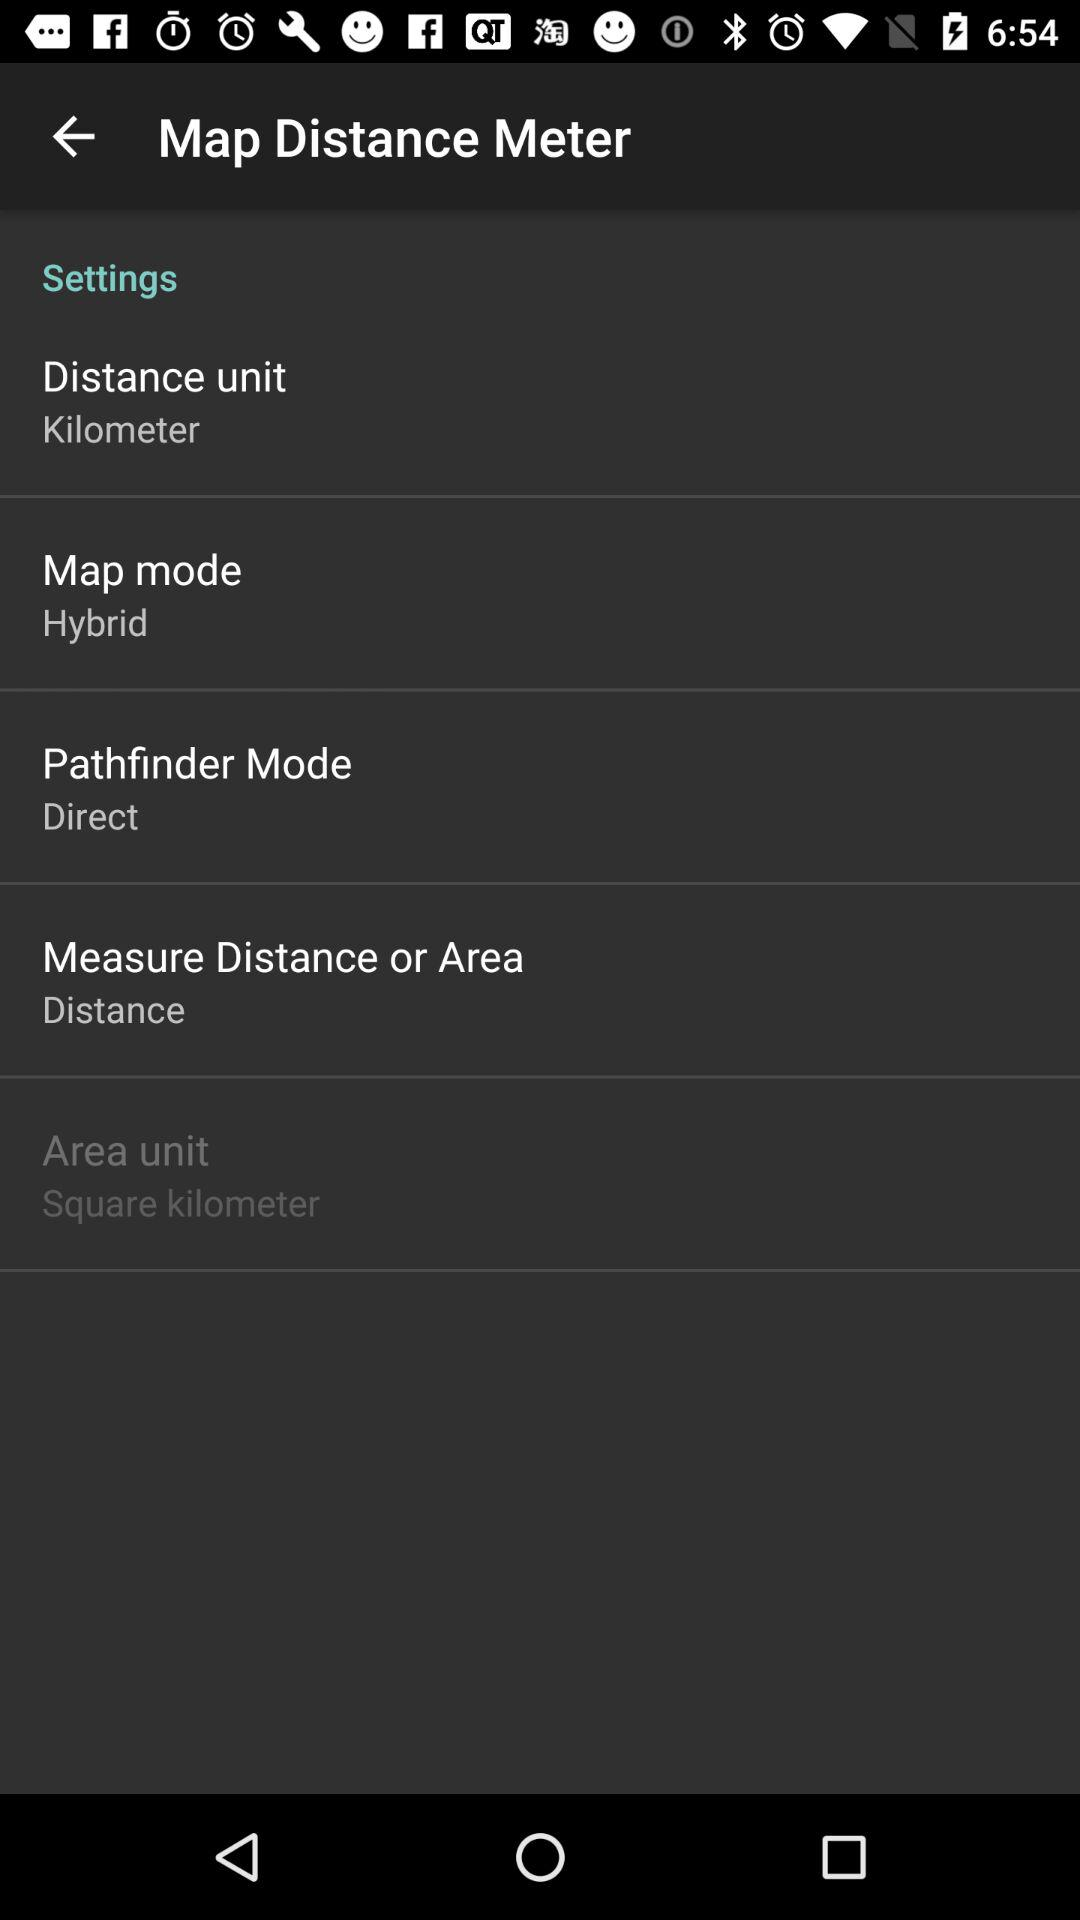What is the setting for "Pathfinder Mode" shown on the screen? The setting is "Direct". 